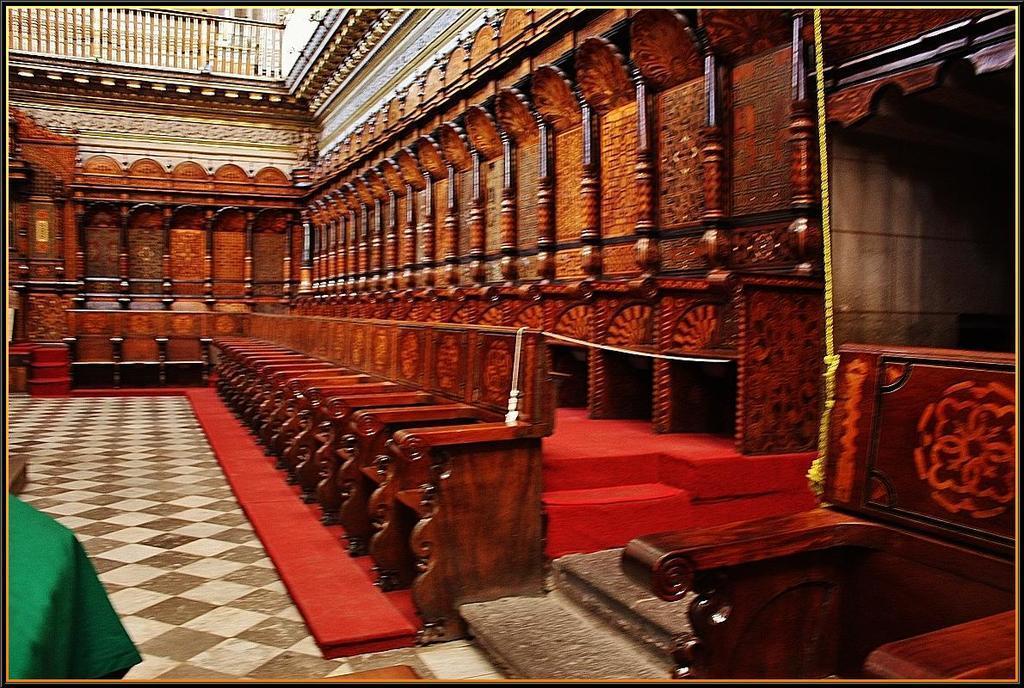Describe this image in one or two sentences. This picture shows inside of the building and couple of chairs. 